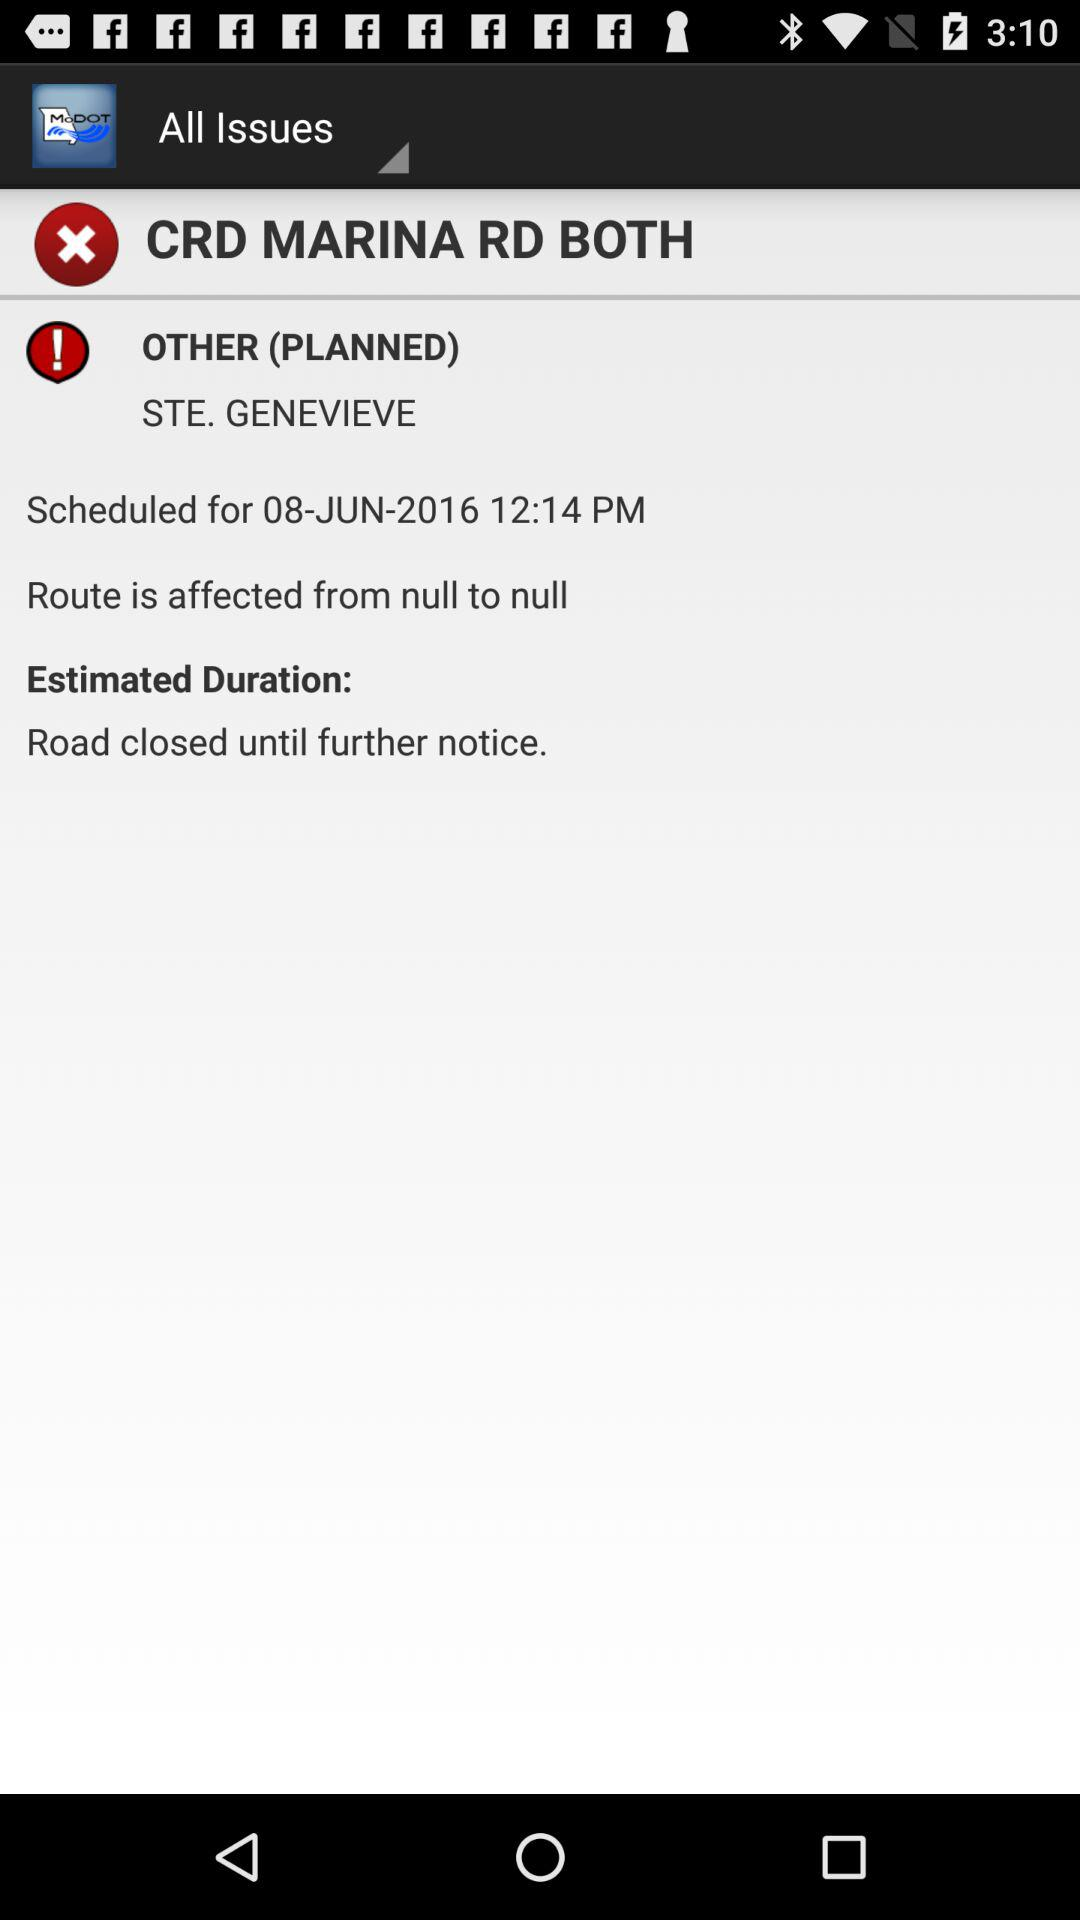How many planned issues are there?
Answer the question using a single word or phrase. 1 